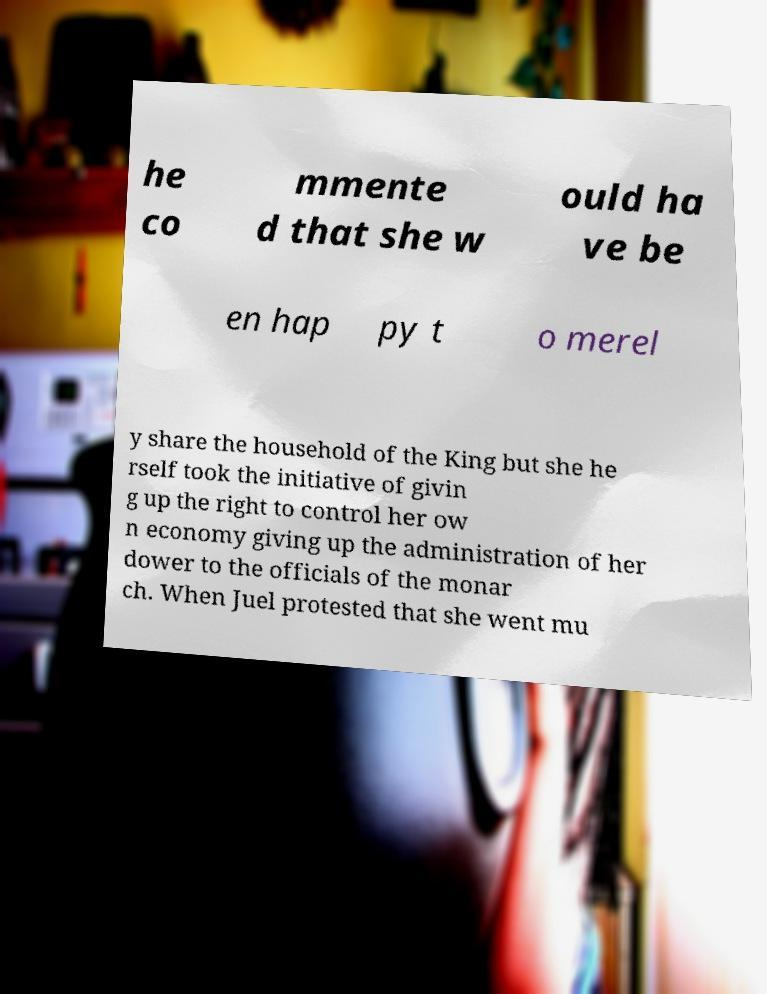Please identify and transcribe the text found in this image. he co mmente d that she w ould ha ve be en hap py t o merel y share the household of the King but she he rself took the initiative of givin g up the right to control her ow n economy giving up the administration of her dower to the officials of the monar ch. When Juel protested that she went mu 